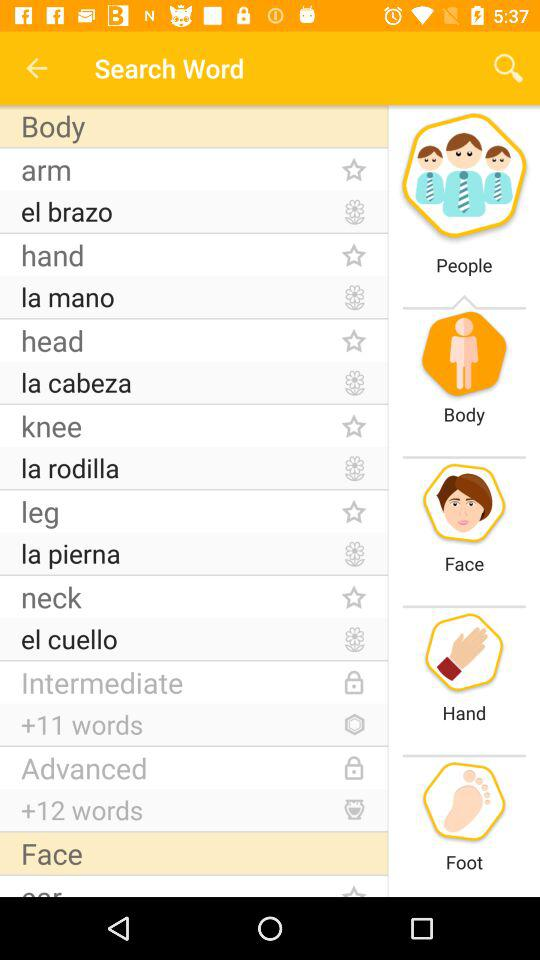Which Body words are Locked?
When the provided information is insufficient, respond with <no answer>. <no answer> 